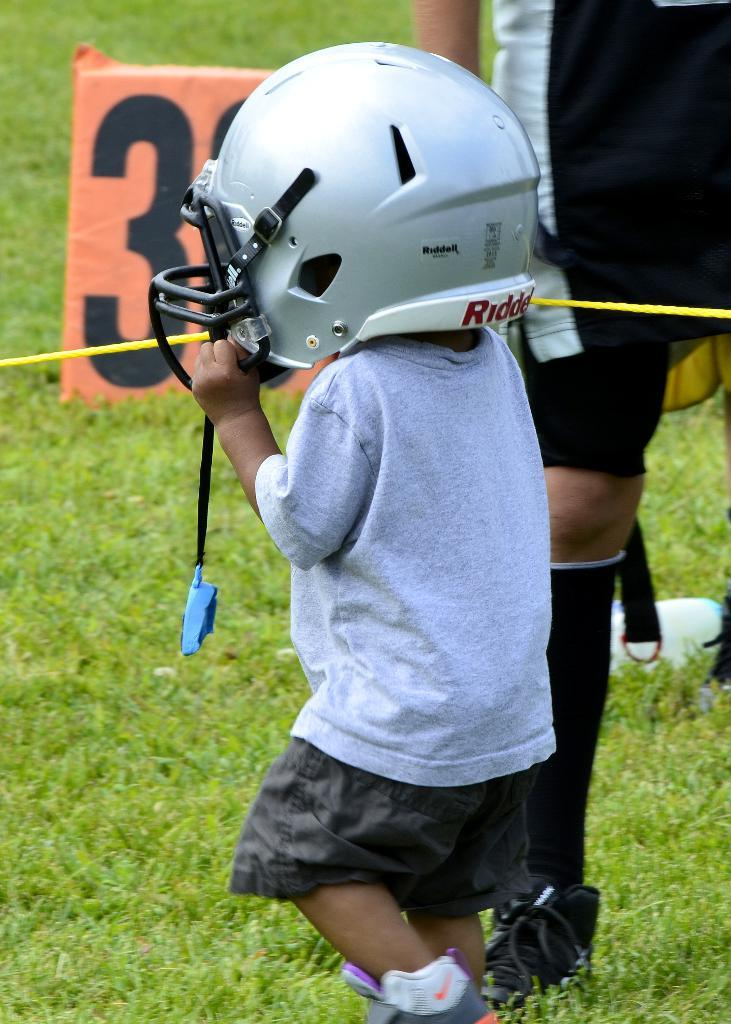What is the main subject of the image? The main subject of the image is a little kid. What is the kid wearing in the image? The kid is wearing a helmet in the image. Who is standing beside the kid? There is a person standing beside the kid in the image. What is the surface that the person is standing on? The person is standing on the surface of the grass in the image. How many books can be seen on the grass in the image? There are no books visible in the image; it only features a little kid wearing a helmet and a person standing beside the kid on the grass. 